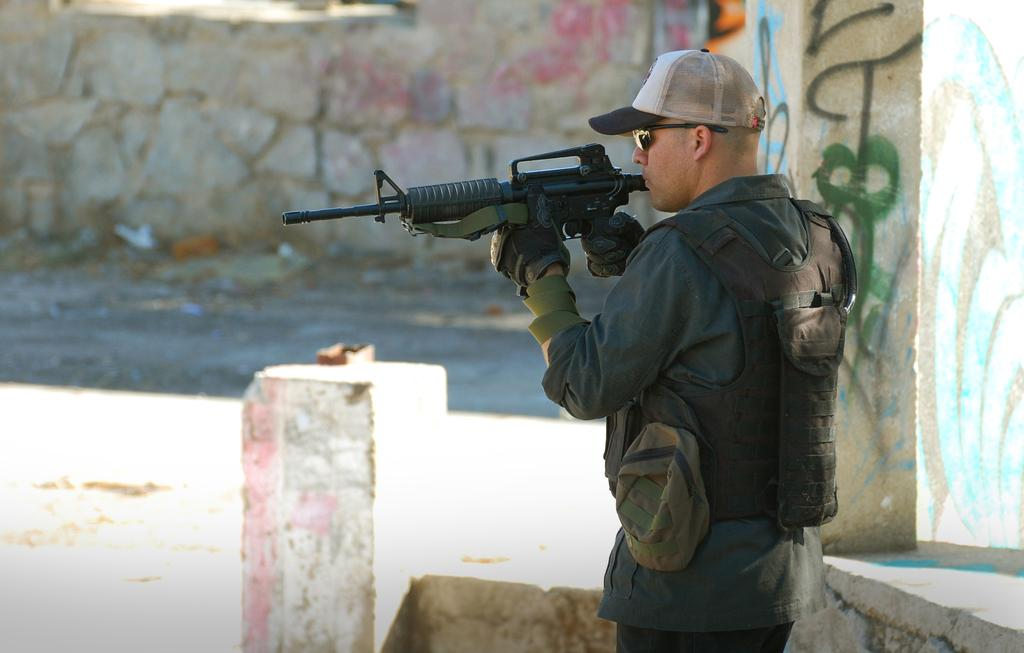What is the main subject in the front of the image? There is a man standing in the front of the image. What is the man holding in the image? The man is holding a gun. What can be seen in the center of the image? There is a pillar in the center of the image. What is visible in the background of the image? There is a wall in the background of the image. What type of stamp is the governor using in the image? There is no stamp or governor present in the image. What month is it in the image? The image does not provide any information about the month or time of year. 